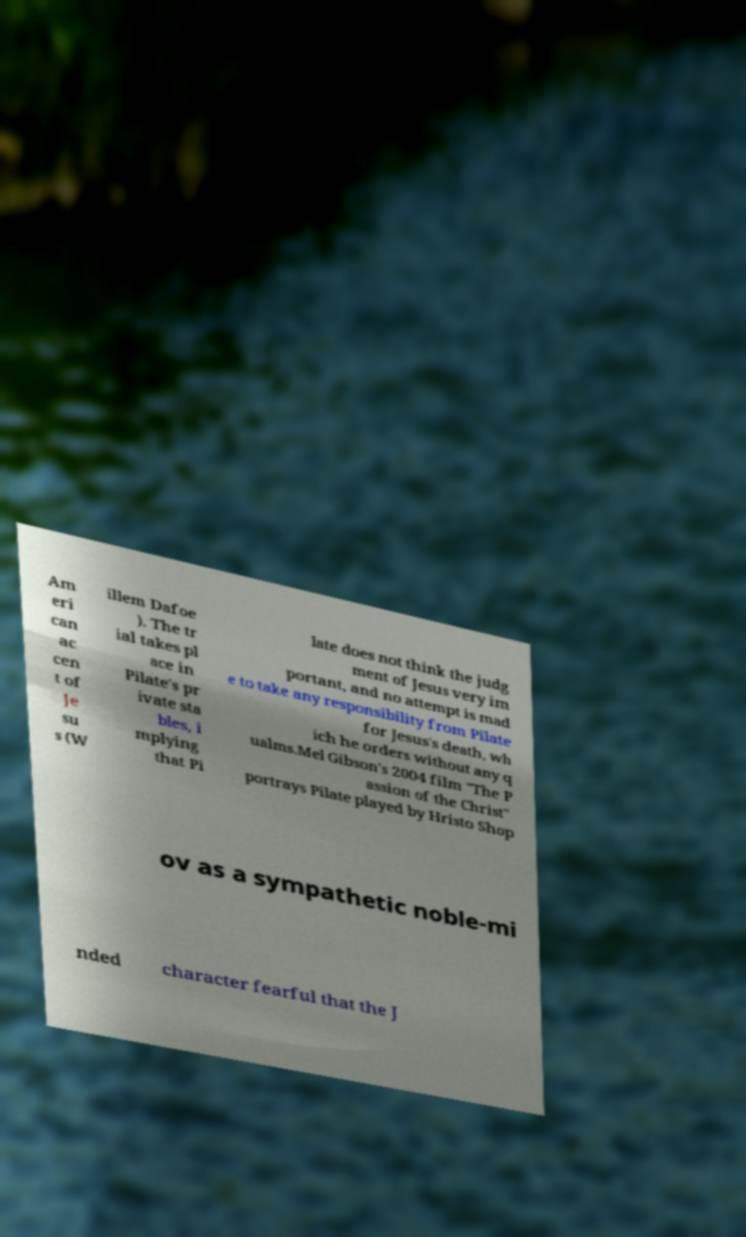I need the written content from this picture converted into text. Can you do that? Am eri can ac cen t of Je su s (W illem Dafoe ). The tr ial takes pl ace in Pilate's pr ivate sta bles, i mplying that Pi late does not think the judg ment of Jesus very im portant, and no attempt is mad e to take any responsibility from Pilate for Jesus's death, wh ich he orders without any q ualms.Mel Gibson's 2004 film "The P assion of the Christ" portrays Pilate played by Hristo Shop ov as a sympathetic noble-mi nded character fearful that the J 